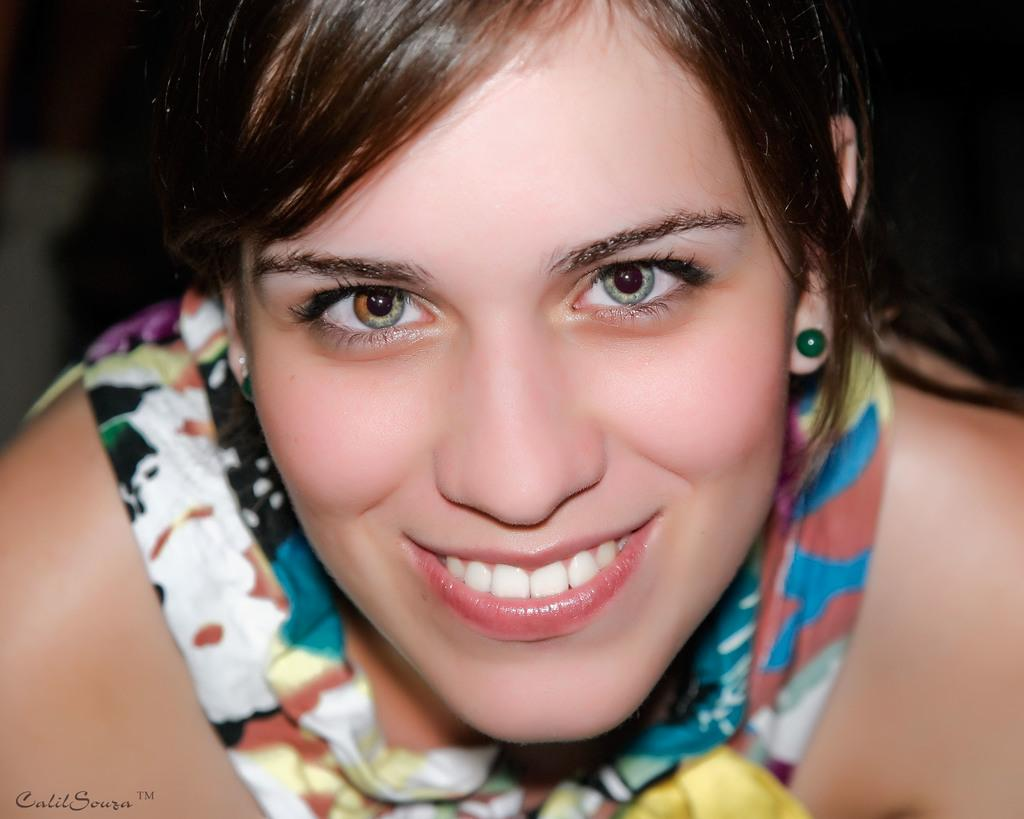Who is present in the image? There is a woman in the image. What is the woman's facial expression? The woman is smiling. What can be observed about the background of the image? The background of the image is dark. What type of meat is the woman cooking in the image? There is no indication of cooking or meat in the image; it only features a woman with a smiling expression and a dark background. 